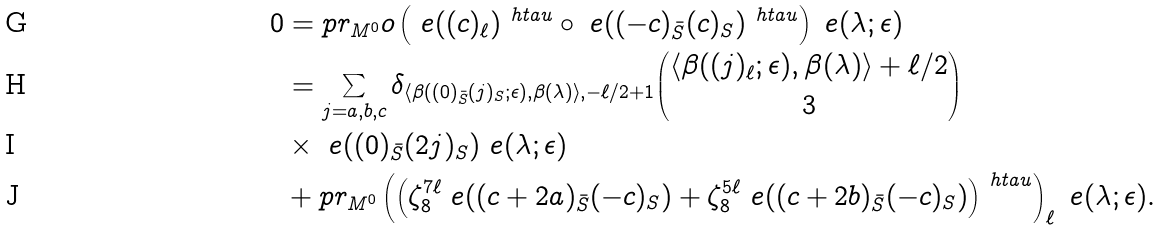Convert formula to latex. <formula><loc_0><loc_0><loc_500><loc_500>0 & = p r _ { M ^ { 0 } } o \left ( \ e ( ( c ) _ { \ell } ) ^ { \ h t a u } \circ \ e ( ( - c ) _ { \bar { S } } ( c ) _ { S } ) ^ { \ h t a u } \right ) \ e ( \lambda ; \epsilon ) \\ & = \sum _ { j = a , b , c } \delta _ { \langle \beta ( ( 0 ) _ { \bar { S } } ( j ) _ { S } ; \epsilon ) , \beta ( \lambda ) \rangle , - { \ell } / 2 + 1 } \binom { \langle \beta ( ( j ) _ { \ell } ; \epsilon ) , \beta ( \lambda ) \rangle + { \ell } / 2 } { 3 } \\ & \times \ e ( ( 0 ) _ { \bar { S } } ( 2 j ) _ { S } ) \ e ( \lambda ; \epsilon ) \\ & + p r _ { M ^ { 0 } } \left ( \left ( \zeta _ { 8 } ^ { 7 \ell } \ e ( ( c + 2 a ) _ { \bar { S } } ( - c ) _ { S } ) + \zeta _ { 8 } ^ { 5 \ell } \ e ( ( c + 2 b ) _ { \bar { S } } ( - c ) _ { S } ) \right ) ^ { \ h t a u } \right ) _ { \ell } \ e ( \lambda ; \epsilon ) .</formula> 